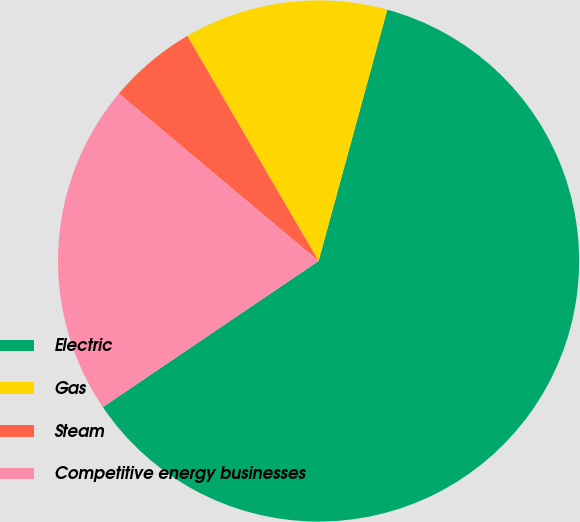Convert chart. <chart><loc_0><loc_0><loc_500><loc_500><pie_chart><fcel>Electric<fcel>Gas<fcel>Steam<fcel>Competitive energy businesses<nl><fcel>61.28%<fcel>12.65%<fcel>5.49%<fcel>20.58%<nl></chart> 